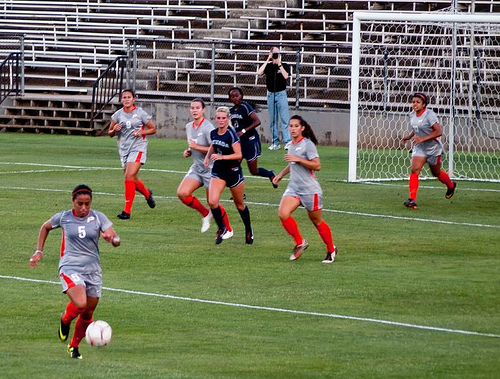<image>
Is the grass on the girl? Yes. Looking at the image, I can see the grass is positioned on top of the girl, with the girl providing support. 